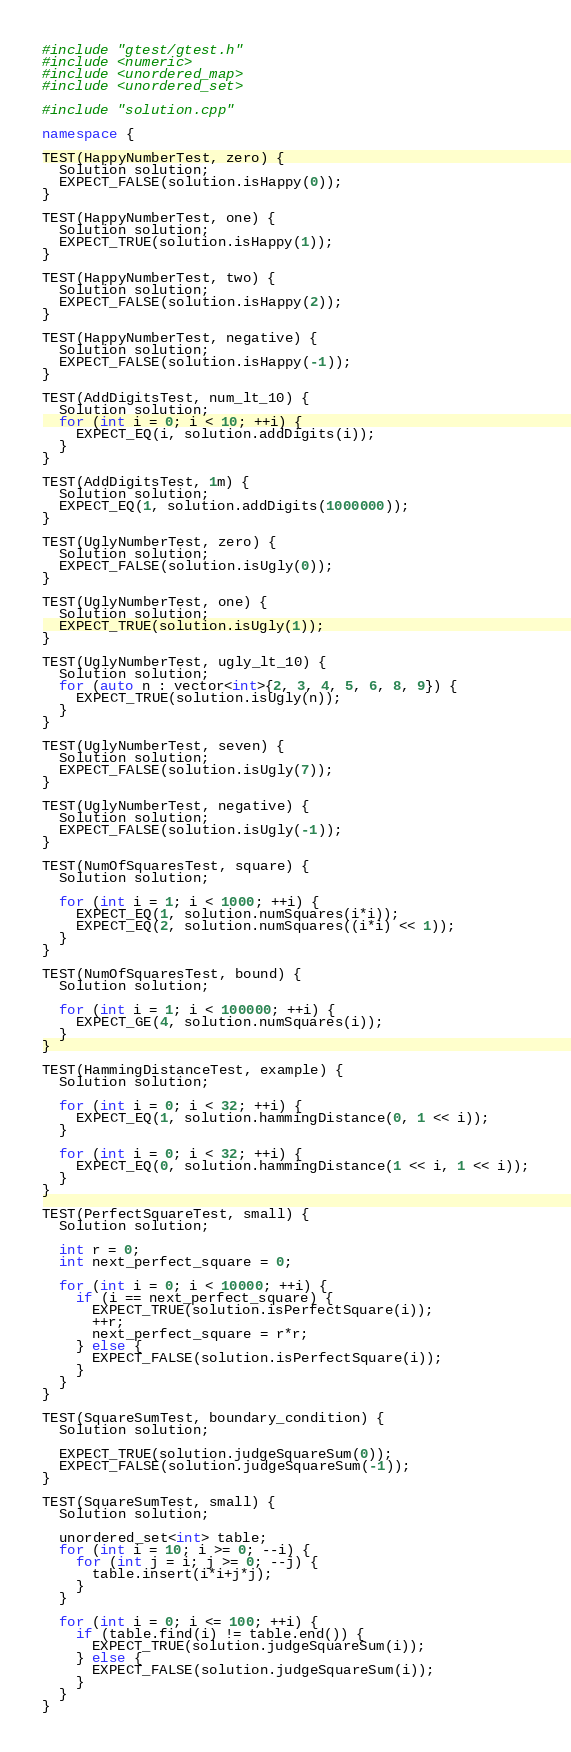Convert code to text. <code><loc_0><loc_0><loc_500><loc_500><_C++_>#include "gtest/gtest.h"
#include <numeric>
#include <unordered_map>
#include <unordered_set>

#include "solution.cpp"

namespace {

TEST(HappyNumberTest, zero) {
  Solution solution;
  EXPECT_FALSE(solution.isHappy(0));
}

TEST(HappyNumberTest, one) {
  Solution solution;
  EXPECT_TRUE(solution.isHappy(1));
}

TEST(HappyNumberTest, two) {
  Solution solution;
  EXPECT_FALSE(solution.isHappy(2));
}

TEST(HappyNumberTest, negative) {
  Solution solution;
  EXPECT_FALSE(solution.isHappy(-1));
}

TEST(AddDigitsTest, num_lt_10) {
  Solution solution;
  for (int i = 0; i < 10; ++i) {
    EXPECT_EQ(i, solution.addDigits(i));
  }
}

TEST(AddDigitsTest, 1m) {
  Solution solution;
  EXPECT_EQ(1, solution.addDigits(1000000));
}

TEST(UglyNumberTest, zero) {
  Solution solution;
  EXPECT_FALSE(solution.isUgly(0));
}

TEST(UglyNumberTest, one) {
  Solution solution;
  EXPECT_TRUE(solution.isUgly(1));
}

TEST(UglyNumberTest, ugly_lt_10) {
  Solution solution;
  for (auto n : vector<int>{2, 3, 4, 5, 6, 8, 9}) {
    EXPECT_TRUE(solution.isUgly(n));
  }
}

TEST(UglyNumberTest, seven) {
  Solution solution;
  EXPECT_FALSE(solution.isUgly(7));
}

TEST(UglyNumberTest, negative) {
  Solution solution;
  EXPECT_FALSE(solution.isUgly(-1));
}

TEST(NumOfSquaresTest, square) {
  Solution solution;

  for (int i = 1; i < 1000; ++i) {
    EXPECT_EQ(1, solution.numSquares(i*i));
    EXPECT_EQ(2, solution.numSquares((i*i) << 1));
  }
}

TEST(NumOfSquaresTest, bound) {
  Solution solution;

  for (int i = 1; i < 100000; ++i) {
    EXPECT_GE(4, solution.numSquares(i));
  }
}

TEST(HammingDistanceTest, example) {
  Solution solution;

  for (int i = 0; i < 32; ++i) {
    EXPECT_EQ(1, solution.hammingDistance(0, 1 << i));
  }

  for (int i = 0; i < 32; ++i) {
    EXPECT_EQ(0, solution.hammingDistance(1 << i, 1 << i));
  }
}

TEST(PerfectSquareTest, small) {
  Solution solution;

  int r = 0;
  int next_perfect_square = 0;

  for (int i = 0; i < 10000; ++i) {
    if (i == next_perfect_square) {
      EXPECT_TRUE(solution.isPerfectSquare(i));
      ++r;
      next_perfect_square = r*r;
    } else {
      EXPECT_FALSE(solution.isPerfectSquare(i));
    }
  }
}

TEST(SquareSumTest, boundary_condition) {
  Solution solution;

  EXPECT_TRUE(solution.judgeSquareSum(0));
  EXPECT_FALSE(solution.judgeSquareSum(-1));
}

TEST(SquareSumTest, small) {
  Solution solution;

  unordered_set<int> table;
  for (int i = 10; i >= 0; --i) {
    for (int j = i; j >= 0; --j) {
      table.insert(i*i+j*j);
    }
  }

  for (int i = 0; i <= 100; ++i) {
    if (table.find(i) != table.end()) {
      EXPECT_TRUE(solution.judgeSquareSum(i));
    } else {
      EXPECT_FALSE(solution.judgeSquareSum(i));
    }
  }
}
</code> 